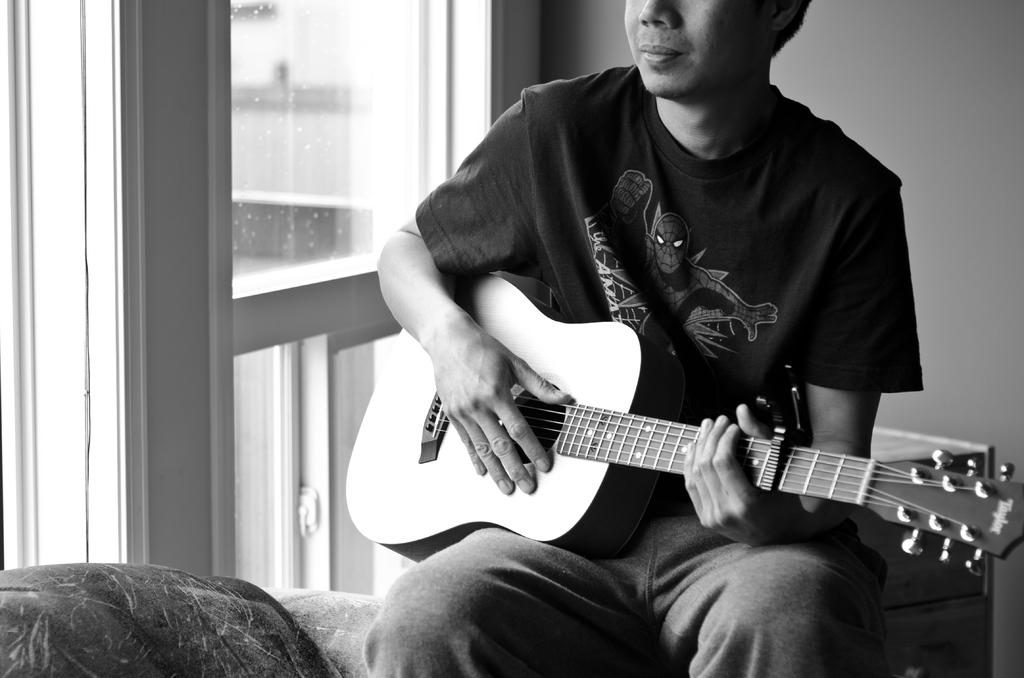What is the color scheme of the image? The image is black and white. Who is present in the image? There is a man in the image. What is the man doing in the image? The man is sitting and playing a guitar. What can be seen in the background of the image? There is a wall in the image. Can you see the man combing his hair in the image? No, there is no comb or any indication of the man combing his hair in the image. 